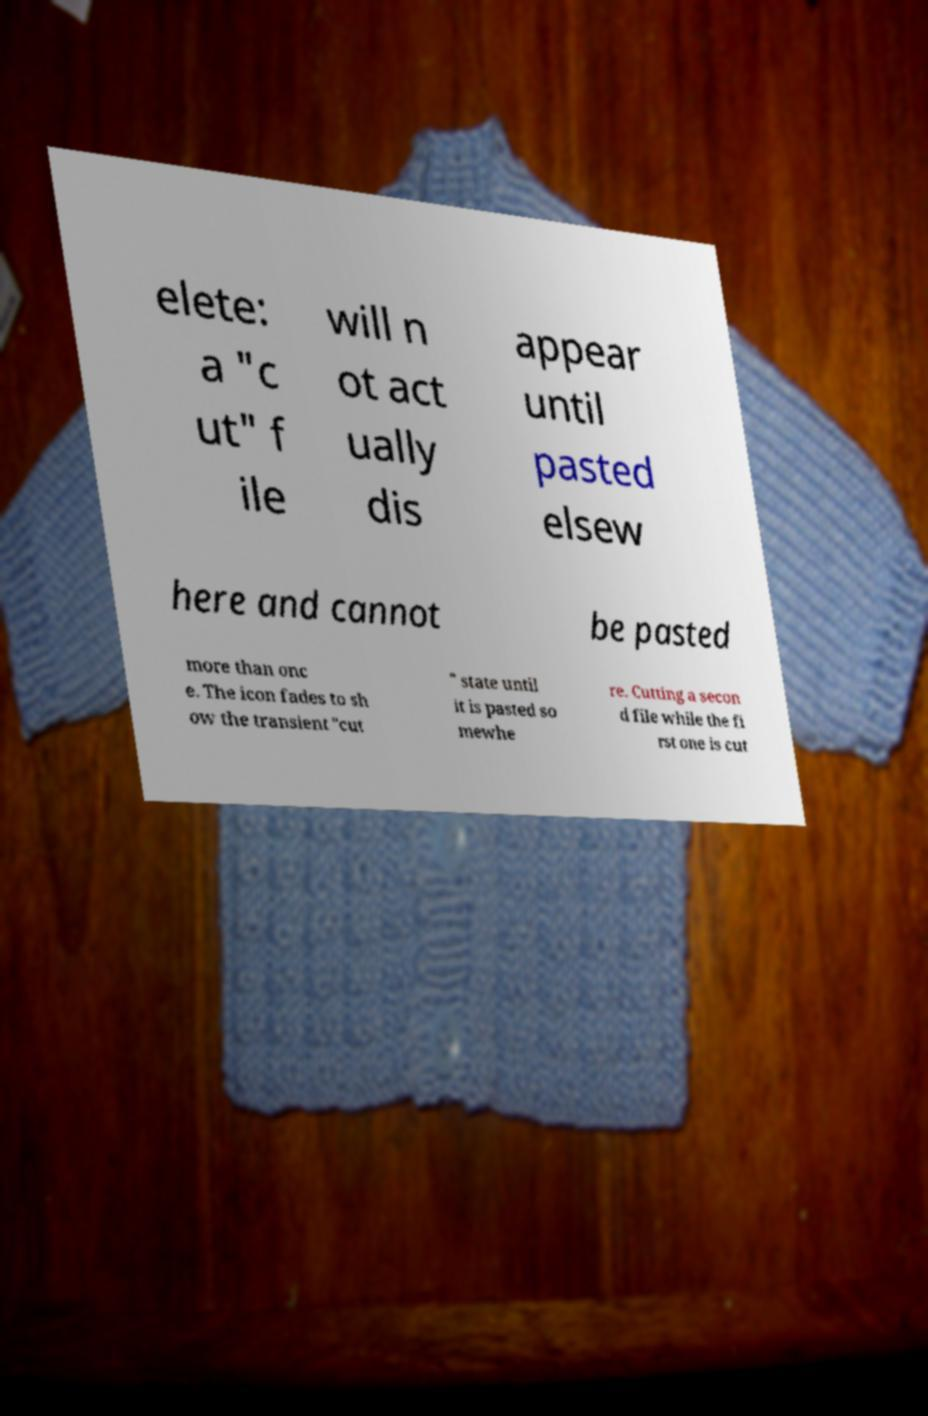Could you extract and type out the text from this image? elete: a "c ut" f ile will n ot act ually dis appear until pasted elsew here and cannot be pasted more than onc e. The icon fades to sh ow the transient "cut " state until it is pasted so mewhe re. Cutting a secon d file while the fi rst one is cut 